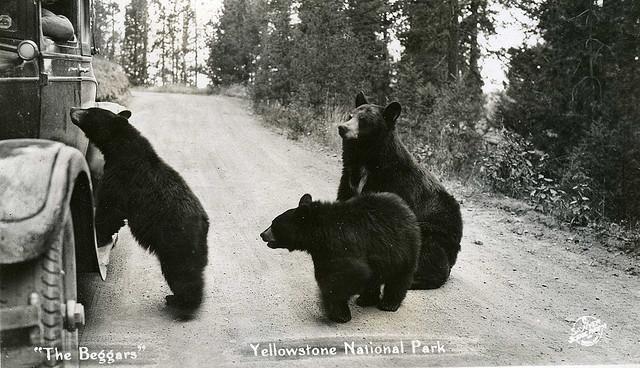How many bears in this photo?
Give a very brief answer. 3. How many bears can be seen?
Give a very brief answer. 3. 